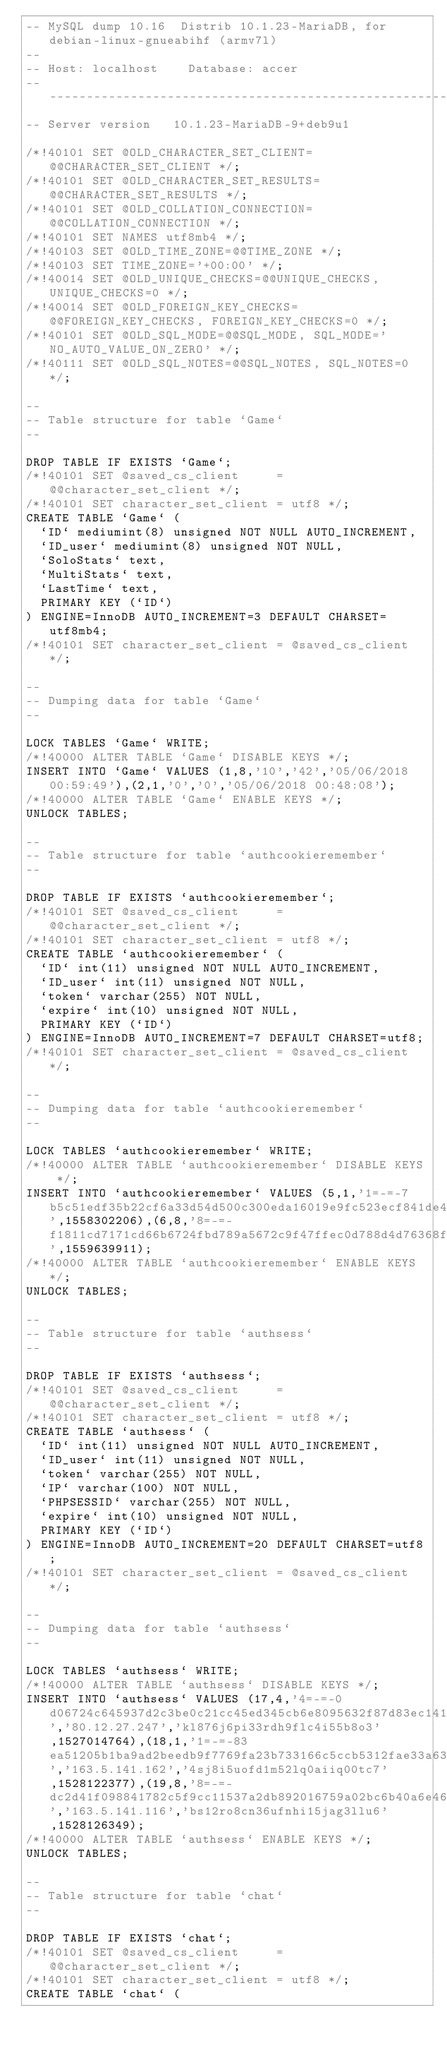Convert code to text. <code><loc_0><loc_0><loc_500><loc_500><_SQL_>-- MySQL dump 10.16  Distrib 10.1.23-MariaDB, for debian-linux-gnueabihf (armv7l)
--
-- Host: localhost    Database: accer
-- ------------------------------------------------------
-- Server version	10.1.23-MariaDB-9+deb9u1

/*!40101 SET @OLD_CHARACTER_SET_CLIENT=@@CHARACTER_SET_CLIENT */;
/*!40101 SET @OLD_CHARACTER_SET_RESULTS=@@CHARACTER_SET_RESULTS */;
/*!40101 SET @OLD_COLLATION_CONNECTION=@@COLLATION_CONNECTION */;
/*!40101 SET NAMES utf8mb4 */;
/*!40103 SET @OLD_TIME_ZONE=@@TIME_ZONE */;
/*!40103 SET TIME_ZONE='+00:00' */;
/*!40014 SET @OLD_UNIQUE_CHECKS=@@UNIQUE_CHECKS, UNIQUE_CHECKS=0 */;
/*!40014 SET @OLD_FOREIGN_KEY_CHECKS=@@FOREIGN_KEY_CHECKS, FOREIGN_KEY_CHECKS=0 */;
/*!40101 SET @OLD_SQL_MODE=@@SQL_MODE, SQL_MODE='NO_AUTO_VALUE_ON_ZERO' */;
/*!40111 SET @OLD_SQL_NOTES=@@SQL_NOTES, SQL_NOTES=0 */;

--
-- Table structure for table `Game`
--

DROP TABLE IF EXISTS `Game`;
/*!40101 SET @saved_cs_client     = @@character_set_client */;
/*!40101 SET character_set_client = utf8 */;
CREATE TABLE `Game` (
  `ID` mediumint(8) unsigned NOT NULL AUTO_INCREMENT,
  `ID_user` mediumint(8) unsigned NOT NULL,
  `SoloStats` text,
  `MultiStats` text,
  `LastTime` text,
  PRIMARY KEY (`ID`)
) ENGINE=InnoDB AUTO_INCREMENT=3 DEFAULT CHARSET=utf8mb4;
/*!40101 SET character_set_client = @saved_cs_client */;

--
-- Dumping data for table `Game`
--

LOCK TABLES `Game` WRITE;
/*!40000 ALTER TABLE `Game` DISABLE KEYS */;
INSERT INTO `Game` VALUES (1,8,'10','42','05/06/2018 00:59:49'),(2,1,'0','0','05/06/2018 00:48:08');
/*!40000 ALTER TABLE `Game` ENABLE KEYS */;
UNLOCK TABLES;

--
-- Table structure for table `authcookieremember`
--

DROP TABLE IF EXISTS `authcookieremember`;
/*!40101 SET @saved_cs_client     = @@character_set_client */;
/*!40101 SET character_set_client = utf8 */;
CREATE TABLE `authcookieremember` (
  `ID` int(11) unsigned NOT NULL AUTO_INCREMENT,
  `ID_user` int(11) unsigned NOT NULL,
  `token` varchar(255) NOT NULL,
  `expire` int(10) unsigned NOT NULL,
  PRIMARY KEY (`ID`)
) ENGINE=InnoDB AUTO_INCREMENT=7 DEFAULT CHARSET=utf8;
/*!40101 SET character_set_client = @saved_cs_client */;

--
-- Dumping data for table `authcookieremember`
--

LOCK TABLES `authcookieremember` WRITE;
/*!40000 ALTER TABLE `authcookieremember` DISABLE KEYS */;
INSERT INTO `authcookieremember` VALUES (5,1,'1=-=-7b5c51edf35b22cf6a33d54d500c300eda16019e9fc523ecf841de4f0ec5f094356a192b7913b04c54574d18c28d46e6395428ab',1558302206),(6,8,'8=-=-f1811cd7171cd66b6724fbd789a5672c9f47ffec0d788d4d76368f920a269380fe5dbbcea5ce7e2988b8c69bcfdfde8904aabc1f',1559639911);
/*!40000 ALTER TABLE `authcookieremember` ENABLE KEYS */;
UNLOCK TABLES;

--
-- Table structure for table `authsess`
--

DROP TABLE IF EXISTS `authsess`;
/*!40101 SET @saved_cs_client     = @@character_set_client */;
/*!40101 SET character_set_client = utf8 */;
CREATE TABLE `authsess` (
  `ID` int(11) unsigned NOT NULL AUTO_INCREMENT,
  `ID_user` int(11) unsigned NOT NULL,
  `token` varchar(255) NOT NULL,
  `IP` varchar(100) NOT NULL,
  `PHPSESSID` varchar(255) NOT NULL,
  `expire` int(10) unsigned NOT NULL,
  PRIMARY KEY (`ID`)
) ENGINE=InnoDB AUTO_INCREMENT=20 DEFAULT CHARSET=utf8;
/*!40101 SET character_set_client = @saved_cs_client */;

--
-- Dumping data for table `authsess`
--

LOCK TABLES `authsess` WRITE;
/*!40000 ALTER TABLE `authsess` DISABLE KEYS */;
INSERT INTO `authsess` VALUES (17,4,'4=-=-0d06724c645937d2c3be0c21cc45ed345cb6e8095632f87d83ec141b321fb2f61b6453892473a467d07372d45eb05abc2031647a','80.12.27.247','kl876j6pi33rdh9flc4i55b8o3',1527014764),(18,1,'1=-=-83ea51205b1ba9ad2beedb9f7769fa23b733166c5ccb5312fae33a632ffca489356a192b7913b04c54574d18c28d46e6395428ab','163.5.141.162','4sj8i5uofd1m52lq0aiiq00tc7',1528122377),(19,8,'8=-=-dc2d41f098841782c5f9cc11537a2db892016759a02bc6b40a6e46b788e01d00fe5dbbcea5ce7e2988b8c69bcfdfde8904aabc1f','163.5.141.116','bs12ro8cn36ufnhi15jag3llu6',1528126349);
/*!40000 ALTER TABLE `authsess` ENABLE KEYS */;
UNLOCK TABLES;

--
-- Table structure for table `chat`
--

DROP TABLE IF EXISTS `chat`;
/*!40101 SET @saved_cs_client     = @@character_set_client */;
/*!40101 SET character_set_client = utf8 */;
CREATE TABLE `chat` (</code> 